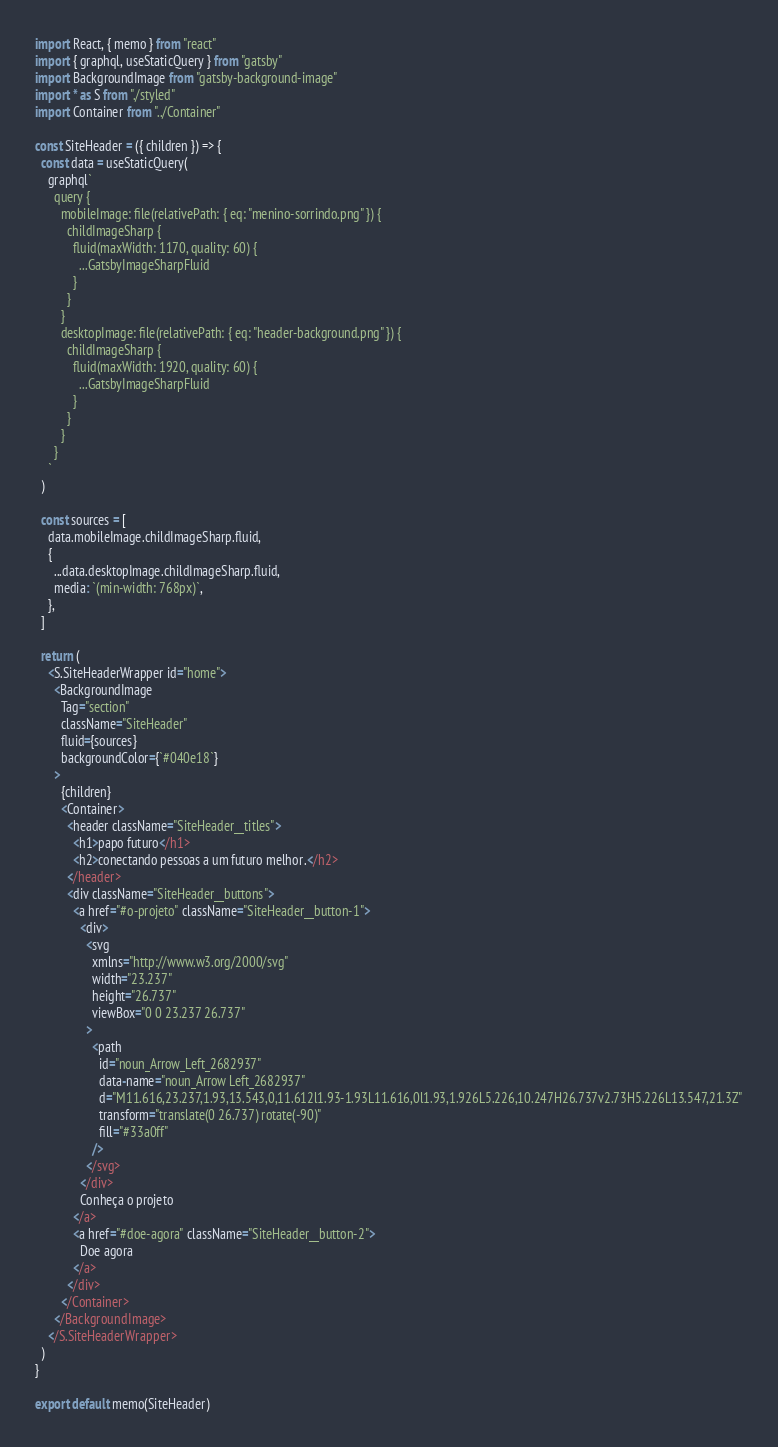Convert code to text. <code><loc_0><loc_0><loc_500><loc_500><_JavaScript_>import React, { memo } from "react"
import { graphql, useStaticQuery } from "gatsby"
import BackgroundImage from "gatsby-background-image"
import * as S from "./styled"
import Container from "../Container"

const SiteHeader = ({ children }) => {
  const data = useStaticQuery(
    graphql`
      query {
        mobileImage: file(relativePath: { eq: "menino-sorrindo.png" }) {
          childImageSharp {
            fluid(maxWidth: 1170, quality: 60) {
              ...GatsbyImageSharpFluid
            }
          }
        }
        desktopImage: file(relativePath: { eq: "header-background.png" }) {
          childImageSharp {
            fluid(maxWidth: 1920, quality: 60) {
              ...GatsbyImageSharpFluid
            }
          }
        }
      }
    `
  )

  const sources = [
    data.mobileImage.childImageSharp.fluid,
    {
      ...data.desktopImage.childImageSharp.fluid,
      media: `(min-width: 768px)`,
    },
  ]

  return (
    <S.SiteHeaderWrapper id="home">
      <BackgroundImage
        Tag="section"
        className="SiteHeader"
        fluid={sources}
        backgroundColor={`#040e18`}
      >
        {children}
        <Container>
          <header className="SiteHeader__titles">
            <h1>papo futuro</h1>
            <h2>conectando pessoas a um futuro melhor.</h2>
          </header>
          <div className="SiteHeader__buttons">
            <a href="#o-projeto" className="SiteHeader__button-1">
              <div>
                <svg
                  xmlns="http://www.w3.org/2000/svg"
                  width="23.237"
                  height="26.737"
                  viewBox="0 0 23.237 26.737"
                >
                  <path
                    id="noun_Arrow_Left_2682937"
                    data-name="noun_Arrow Left_2682937"
                    d="M11.616,23.237,1.93,13.543,0,11.612l1.93-1.93L11.616,0l1.93,1.926L5.226,10.247H26.737v2.73H5.226L13.547,21.3Z"
                    transform="translate(0 26.737) rotate(-90)"
                    fill="#33a0ff"
                  />
                </svg>
              </div>
              Conheça o projeto
            </a>
            <a href="#doe-agora" className="SiteHeader__button-2">
              Doe agora
            </a>
          </div>
        </Container>
      </BackgroundImage>
    </S.SiteHeaderWrapper>
  )
}

export default memo(SiteHeader)
</code> 